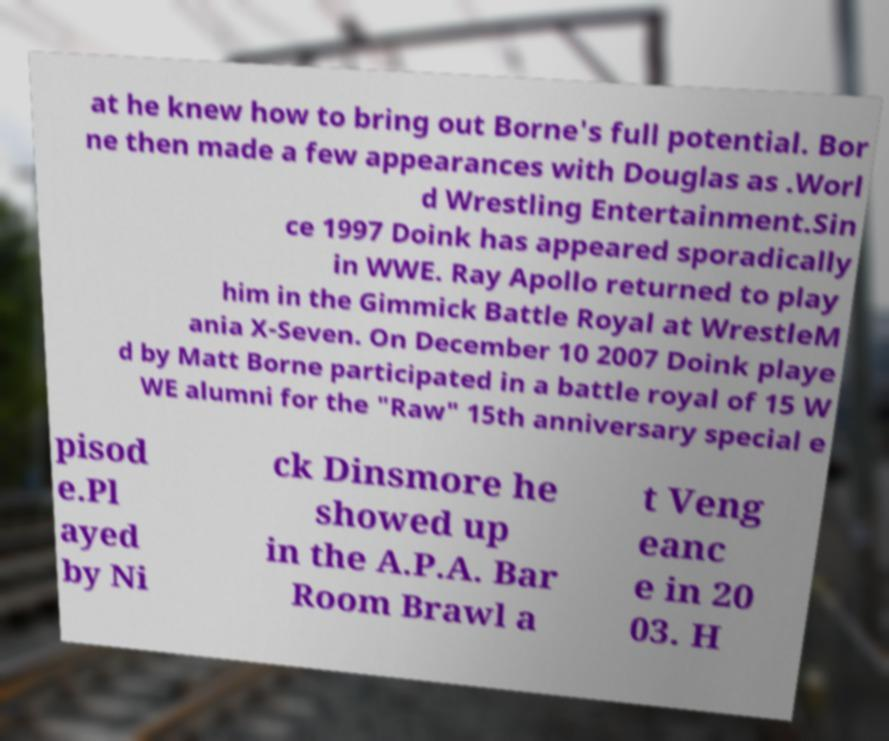Could you assist in decoding the text presented in this image and type it out clearly? at he knew how to bring out Borne's full potential. Bor ne then made a few appearances with Douglas as .Worl d Wrestling Entertainment.Sin ce 1997 Doink has appeared sporadically in WWE. Ray Apollo returned to play him in the Gimmick Battle Royal at WrestleM ania X-Seven. On December 10 2007 Doink playe d by Matt Borne participated in a battle royal of 15 W WE alumni for the "Raw" 15th anniversary special e pisod e.Pl ayed by Ni ck Dinsmore he showed up in the A.P.A. Bar Room Brawl a t Veng eanc e in 20 03. H 